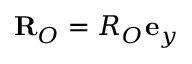<formula> <loc_0><loc_0><loc_500><loc_500>R _ { O } = R _ { O } e _ { y }</formula> 